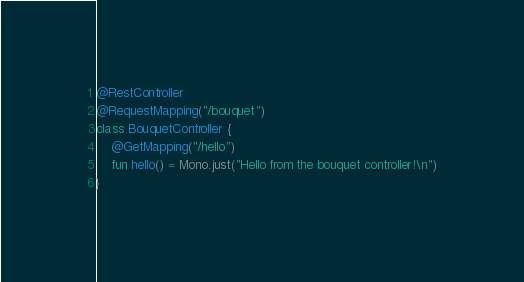<code> <loc_0><loc_0><loc_500><loc_500><_Kotlin_>
@RestController
@RequestMapping("/bouquet")
class BouquetController {
    @GetMapping("/hello")
    fun hello() = Mono.just("Hello from the bouquet controller!\n")
}</code> 